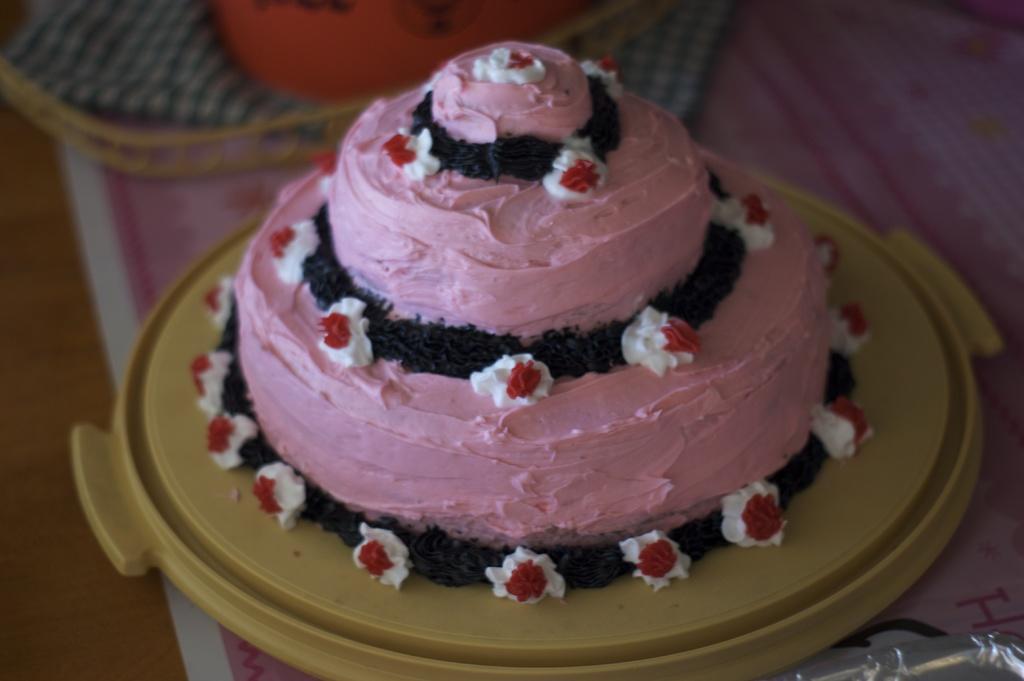Describe this image in one or two sentences. In this image there is a table with a paper, a basket with a napkin and a tray with a cake on it. There is a cream which is pink in color on the cake. 